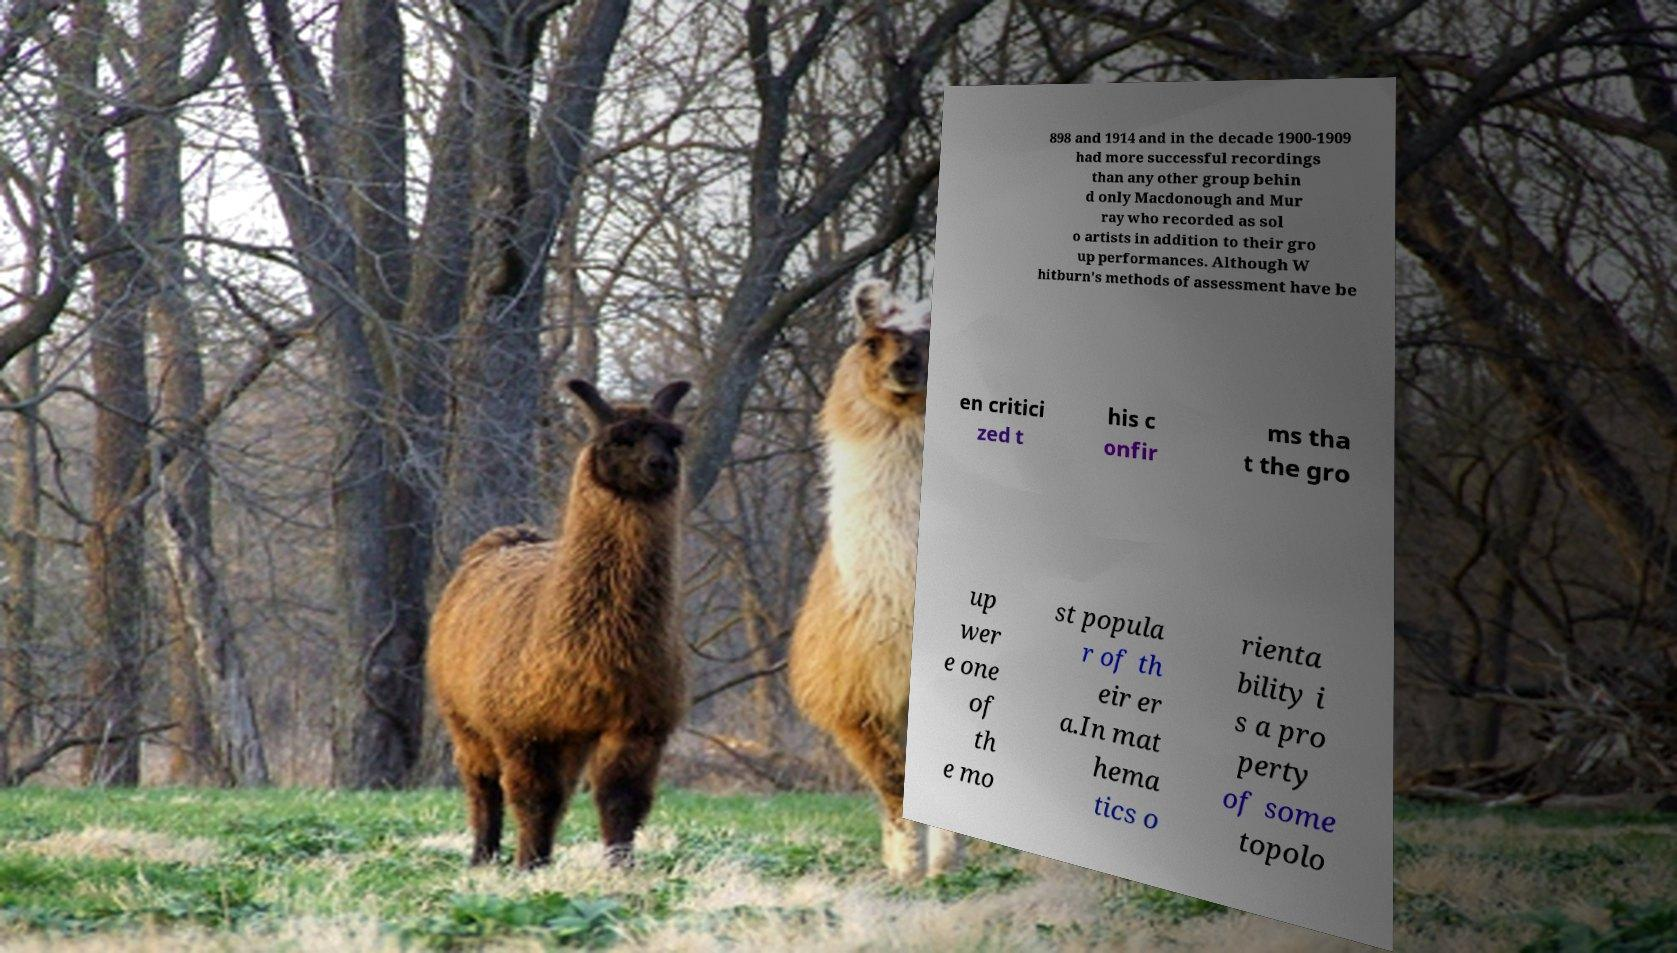What messages or text are displayed in this image? I need them in a readable, typed format. 898 and 1914 and in the decade 1900-1909 had more successful recordings than any other group behin d only Macdonough and Mur ray who recorded as sol o artists in addition to their gro up performances. Although W hitburn's methods of assessment have be en critici zed t his c onfir ms tha t the gro up wer e one of th e mo st popula r of th eir er a.In mat hema tics o rienta bility i s a pro perty of some topolo 